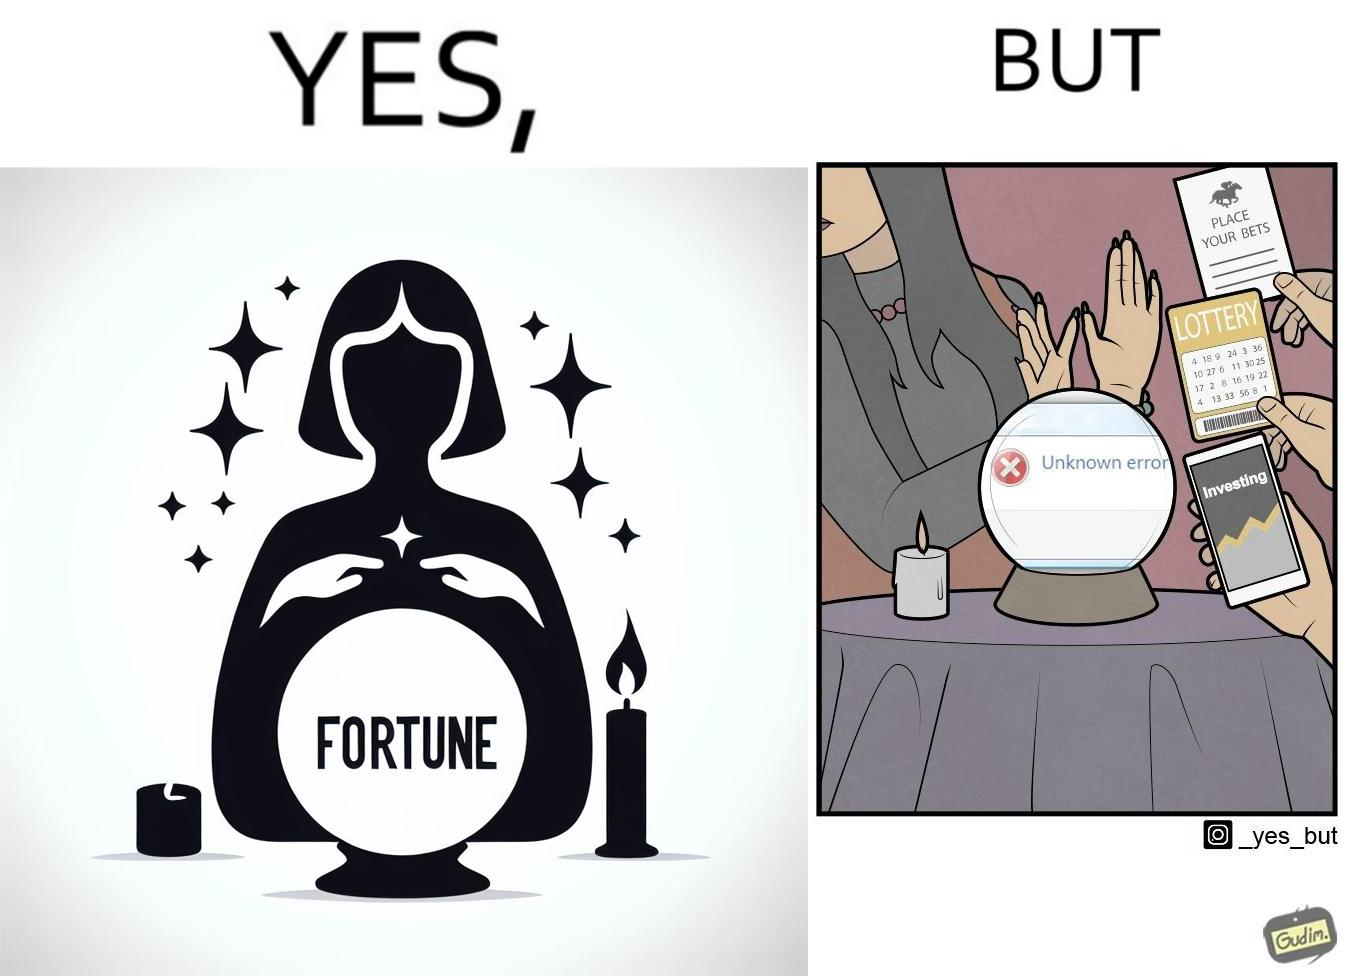Describe what you see in this image. The people who claim to predict the future either find their predictions unsuccessful or avoid themselves from making claims related to finance, lotteries, and bets. 